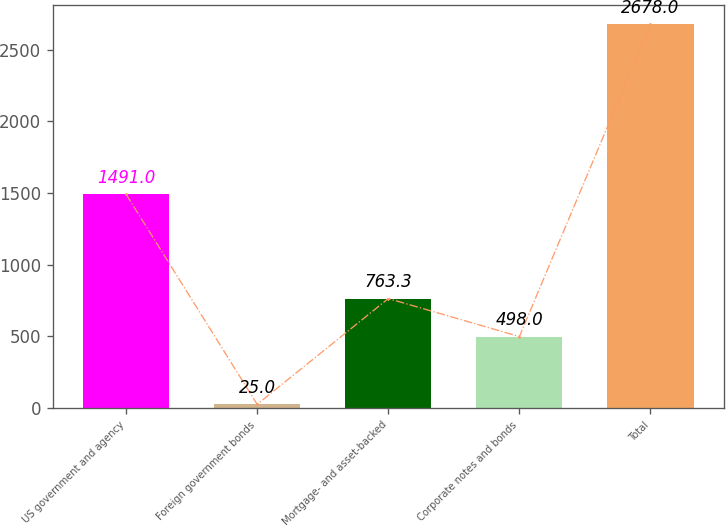Convert chart to OTSL. <chart><loc_0><loc_0><loc_500><loc_500><bar_chart><fcel>US government and agency<fcel>Foreign government bonds<fcel>Mortgage- and asset-backed<fcel>Corporate notes and bonds<fcel>Total<nl><fcel>1491<fcel>25<fcel>763.3<fcel>498<fcel>2678<nl></chart> 